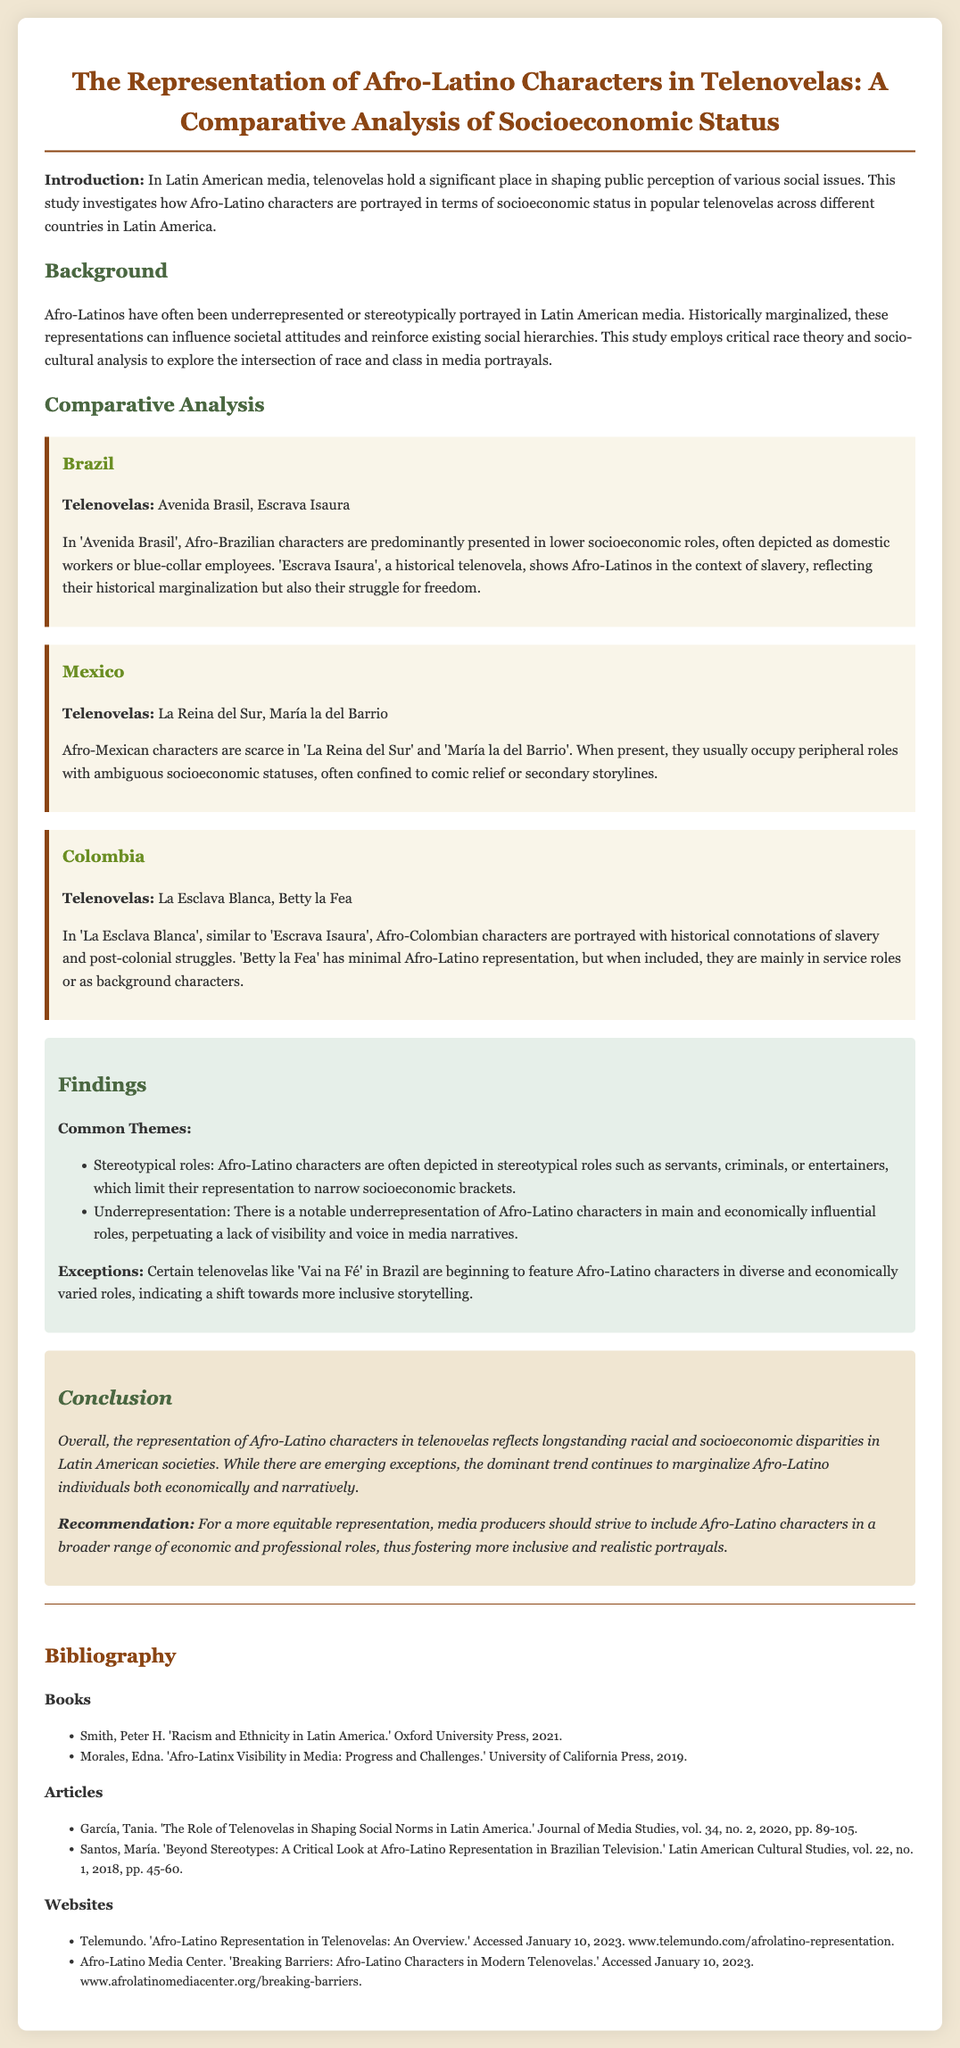What is the title of the document? The title is found in the header of the document, which is "The Representation of Afro-Latino Characters in Telenovelas: A Comparative Analysis of Socioeconomic Status".
Answer: The Representation of Afro-Latino Characters in Telenovelas: A Comparative Analysis of Socioeconomic Status Which country is mentioned first in the comparative analysis? The first country mentioned in the comparative analysis section is Brazil, as found in the structure of the document.
Answer: Brazil Name one telenovela from the Colombia section. The Colombia section lists "La Esclava Blanca" and "Betty la Fea," but only one is needed.
Answer: La Esclava Blanca What common theme is highlighted in the findings? The findings section outlines several themes, one being "Stereotypical roles" as a recurring issue in representations.
Answer: Stereotypical roles What is the recommendation stated in the conclusion? The recommendation can be found at the end of the conclusion, which suggests that media producers strive to include Afro-Latino characters in more diverse roles.
Answer: Include Afro-Latino characters in a broader range of economic and professional roles How many articles are listed in the bibliography? The bibliography section shows that there are two articles listed, providing a clear count from the document.
Answer: 2 Which historical context is reflected in the telenovela "Escrava Isaura"? The document specifies that "Escrava Isaura" portrays Afro-Latinos in the context of slavery, reflecting a significant historical issue.
Answer: Slavery What is the predominant socioeconomic role of Afro-Brazilian characters in "Avenida Brasil"? The document states that Afro-Brazilian characters are predominantly presented in lower socioeconomic roles in "Avenida Brasil."
Answer: Lower socioeconomic roles What is the background color of the findings section? The findings section is described as having a specific background color in the styling elements of the document.
Answer: #e6efe9 